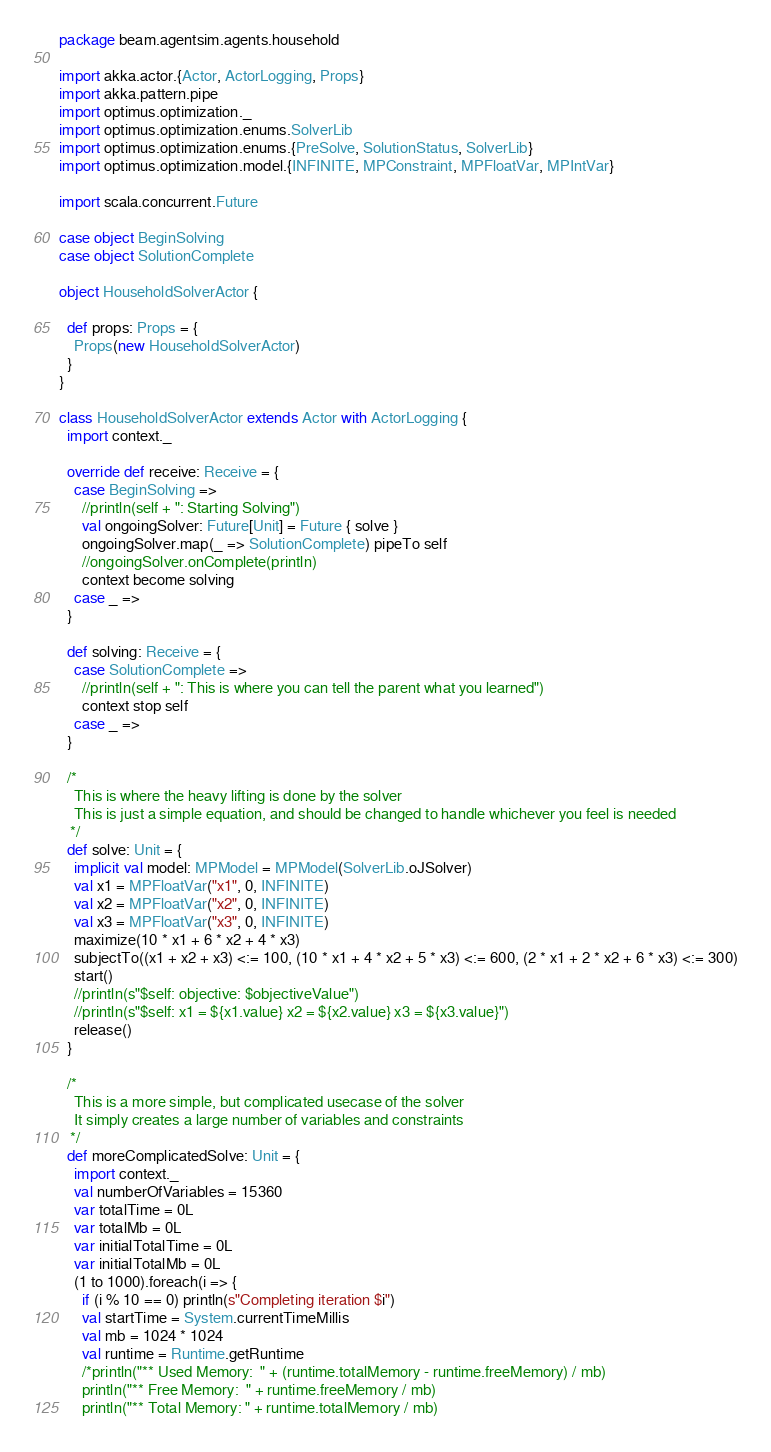Convert code to text. <code><loc_0><loc_0><loc_500><loc_500><_Scala_>package beam.agentsim.agents.household

import akka.actor.{Actor, ActorLogging, Props}
import akka.pattern.pipe
import optimus.optimization._
import optimus.optimization.enums.SolverLib
import optimus.optimization.enums.{PreSolve, SolutionStatus, SolverLib}
import optimus.optimization.model.{INFINITE, MPConstraint, MPFloatVar, MPIntVar}

import scala.concurrent.Future

case object BeginSolving
case object SolutionComplete

object HouseholdSolverActor {

  def props: Props = {
    Props(new HouseholdSolverActor)
  }
}

class HouseholdSolverActor extends Actor with ActorLogging {
  import context._

  override def receive: Receive = {
    case BeginSolving =>
      //println(self + ": Starting Solving")
      val ongoingSolver: Future[Unit] = Future { solve }
      ongoingSolver.map(_ => SolutionComplete) pipeTo self
      //ongoingSolver.onComplete(println)
      context become solving
    case _ =>
  }

  def solving: Receive = {
    case SolutionComplete =>
      //println(self + ": This is where you can tell the parent what you learned")
      context stop self
    case _ =>
  }

  /*
    This is where the heavy lifting is done by the solver
    This is just a simple equation, and should be changed to handle whichever you feel is needed
   */
  def solve: Unit = {
    implicit val model: MPModel = MPModel(SolverLib.oJSolver)
    val x1 = MPFloatVar("x1", 0, INFINITE)
    val x2 = MPFloatVar("x2", 0, INFINITE)
    val x3 = MPFloatVar("x3", 0, INFINITE)
    maximize(10 * x1 + 6 * x2 + 4 * x3)
    subjectTo((x1 + x2 + x3) <:= 100, (10 * x1 + 4 * x2 + 5 * x3) <:= 600, (2 * x1 + 2 * x2 + 6 * x3) <:= 300)
    start()
    //println(s"$self: objective: $objectiveValue")
    //println(s"$self: x1 = ${x1.value} x2 = ${x2.value} x3 = ${x3.value}")
    release()
  }

  /*
    This is a more simple, but complicated usecase of the solver
    It simply creates a large number of variables and constraints
   */
  def moreComplicatedSolve: Unit = {
    import context._
    val numberOfVariables = 15360
    var totalTime = 0L
    var totalMb = 0L
    var initialTotalTime = 0L
    var initialTotalMb = 0L
    (1 to 1000).foreach(i => {
      if (i % 10 == 0) println(s"Completing iteration $i")
      val startTime = System.currentTimeMillis
      val mb = 1024 * 1024
      val runtime = Runtime.getRuntime
      /*println("** Used Memory:  " + (runtime.totalMemory - runtime.freeMemory) / mb)
      println("** Free Memory:  " + runtime.freeMemory / mb)
      println("** Total Memory: " + runtime.totalMemory / mb)</code> 